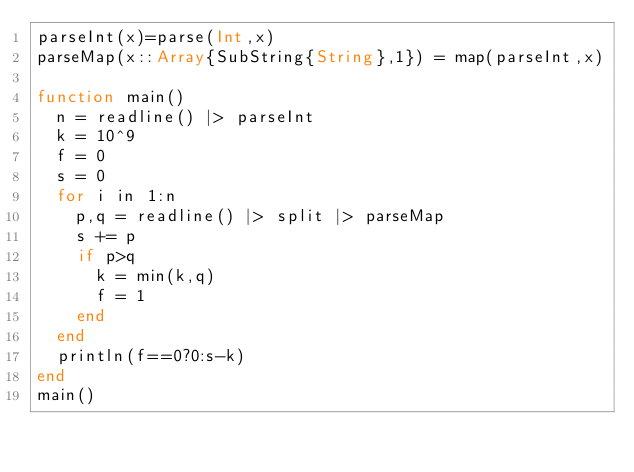<code> <loc_0><loc_0><loc_500><loc_500><_Julia_>parseInt(x)=parse(Int,x)
parseMap(x::Array{SubString{String},1}) = map(parseInt,x)

function main()
	n = readline() |> parseInt
	k = 10^9
	f = 0
	s = 0
	for i in 1:n
		p,q = readline() |> split |> parseMap
		s += p
		if p>q
			k = min(k,q)
			f = 1
		end
	end
	println(f==0?0:s-k)
end
main()
</code> 